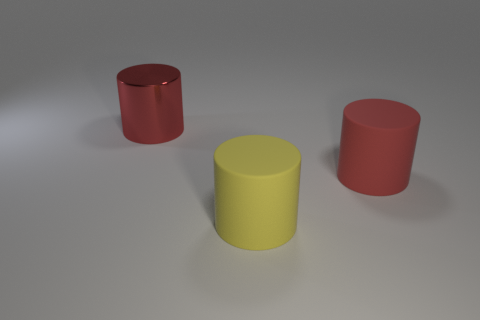Add 3 purple metallic balls. How many objects exist? 6 Add 1 large matte objects. How many large matte objects are left? 3 Add 3 big shiny cylinders. How many big shiny cylinders exist? 4 Subtract 0 blue balls. How many objects are left? 3 Subtract all big red objects. Subtract all big yellow metallic cylinders. How many objects are left? 1 